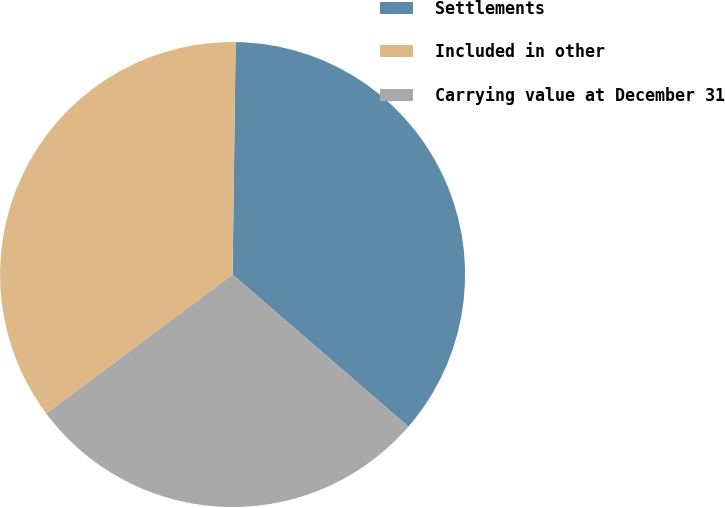Convert chart. <chart><loc_0><loc_0><loc_500><loc_500><pie_chart><fcel>Settlements<fcel>Included in other<fcel>Carrying value at December 31<nl><fcel>36.14%<fcel>35.41%<fcel>28.45%<nl></chart> 